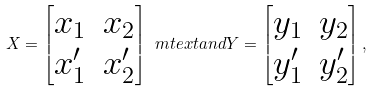<formula> <loc_0><loc_0><loc_500><loc_500>X = \begin{bmatrix} x _ { 1 } & x _ { 2 } \\ x _ { 1 } ^ { \prime } & x _ { 2 } ^ { \prime } \end{bmatrix} \ m t e x t { a n d } Y = \begin{bmatrix} y _ { 1 } & y _ { 2 } \\ y _ { 1 } ^ { \prime } & y _ { 2 } ^ { \prime } \end{bmatrix} ,</formula> 